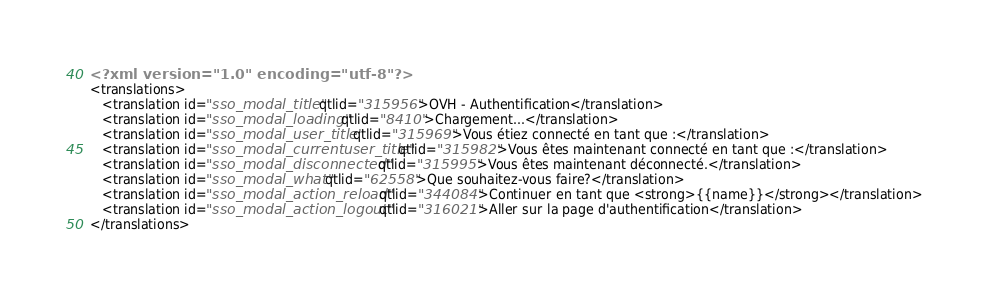Convert code to text. <code><loc_0><loc_0><loc_500><loc_500><_XML_><?xml version="1.0" encoding="utf-8"?>
<translations>
   <translation id="sso_modal_title" qtlid="315956">OVH - Authentification</translation>
   <translation id="sso_modal_loading" qtlid="8410">Chargement...</translation>
   <translation id="sso_modal_user_title" qtlid="315969">Vous étiez connecté en tant que :</translation>
   <translation id="sso_modal_currentuser_title" qtlid="315982">Vous êtes maintenant connecté en tant que :</translation>
   <translation id="sso_modal_disconnected" qtlid="315995">Vous êtes maintenant déconnecté.</translation>
   <translation id="sso_modal_what" qtlid="62558">Que souhaitez-vous faire?</translation>
   <translation id="sso_modal_action_reload" qtlid="344084">Continuer en tant que <strong>{{name}}</strong></translation>
   <translation id="sso_modal_action_logout" qtlid="316021">Aller sur la page d'authentification</translation>
</translations>
</code> 